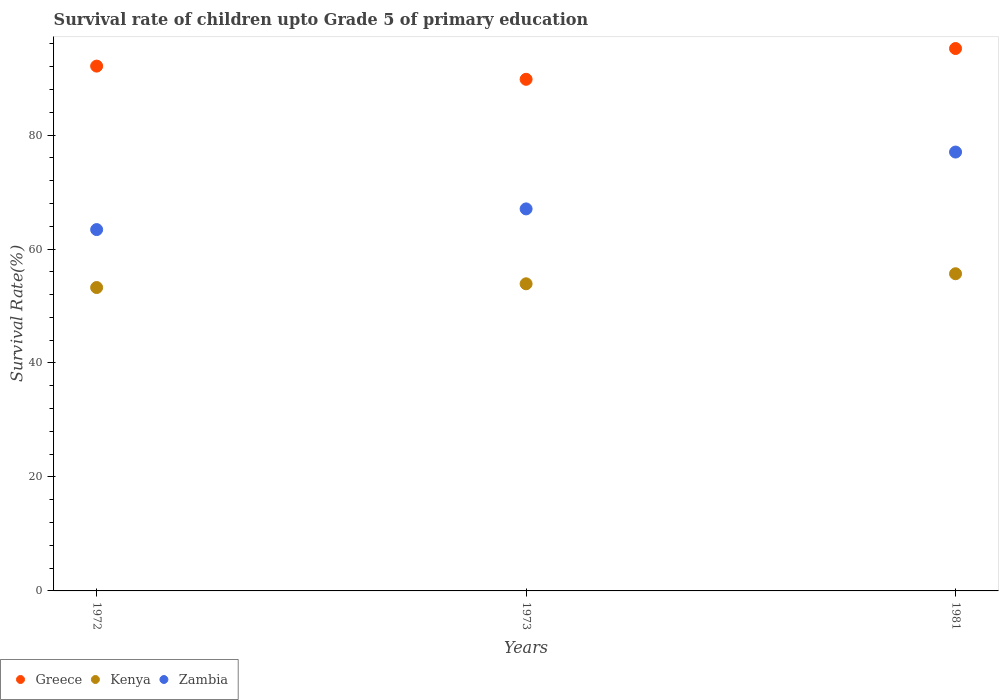What is the survival rate of children in Kenya in 1972?
Your answer should be compact. 53.24. Across all years, what is the maximum survival rate of children in Greece?
Provide a succinct answer. 95.19. Across all years, what is the minimum survival rate of children in Greece?
Ensure brevity in your answer.  89.79. In which year was the survival rate of children in Kenya maximum?
Give a very brief answer. 1981. In which year was the survival rate of children in Kenya minimum?
Your response must be concise. 1972. What is the total survival rate of children in Zambia in the graph?
Provide a short and direct response. 207.48. What is the difference between the survival rate of children in Greece in 1973 and that in 1981?
Ensure brevity in your answer.  -5.4. What is the difference between the survival rate of children in Zambia in 1972 and the survival rate of children in Kenya in 1981?
Your response must be concise. 7.75. What is the average survival rate of children in Greece per year?
Keep it short and to the point. 92.36. In the year 1973, what is the difference between the survival rate of children in Kenya and survival rate of children in Zambia?
Your response must be concise. -13.15. In how many years, is the survival rate of children in Zambia greater than 68 %?
Provide a short and direct response. 1. What is the ratio of the survival rate of children in Zambia in 1972 to that in 1973?
Provide a succinct answer. 0.95. Is the survival rate of children in Zambia in 1972 less than that in 1973?
Provide a short and direct response. Yes. Is the difference between the survival rate of children in Kenya in 1973 and 1981 greater than the difference between the survival rate of children in Zambia in 1973 and 1981?
Offer a terse response. Yes. What is the difference between the highest and the second highest survival rate of children in Kenya?
Give a very brief answer. 1.76. What is the difference between the highest and the lowest survival rate of children in Greece?
Offer a very short reply. 5.4. Is it the case that in every year, the sum of the survival rate of children in Kenya and survival rate of children in Zambia  is greater than the survival rate of children in Greece?
Give a very brief answer. Yes. Does the survival rate of children in Zambia monotonically increase over the years?
Make the answer very short. Yes. Is the survival rate of children in Kenya strictly greater than the survival rate of children in Greece over the years?
Your answer should be compact. No. How many dotlines are there?
Offer a very short reply. 3. What is the difference between two consecutive major ticks on the Y-axis?
Your answer should be very brief. 20. Does the graph contain any zero values?
Your response must be concise. No. Where does the legend appear in the graph?
Your answer should be very brief. Bottom left. How are the legend labels stacked?
Ensure brevity in your answer.  Horizontal. What is the title of the graph?
Provide a short and direct response. Survival rate of children upto Grade 5 of primary education. What is the label or title of the X-axis?
Offer a very short reply. Years. What is the label or title of the Y-axis?
Your response must be concise. Survival Rate(%). What is the Survival Rate(%) in Greece in 1972?
Provide a succinct answer. 92.1. What is the Survival Rate(%) in Kenya in 1972?
Ensure brevity in your answer.  53.24. What is the Survival Rate(%) of Zambia in 1972?
Your response must be concise. 63.41. What is the Survival Rate(%) of Greece in 1973?
Keep it short and to the point. 89.79. What is the Survival Rate(%) of Kenya in 1973?
Keep it short and to the point. 53.9. What is the Survival Rate(%) of Zambia in 1973?
Offer a terse response. 67.04. What is the Survival Rate(%) of Greece in 1981?
Keep it short and to the point. 95.19. What is the Survival Rate(%) in Kenya in 1981?
Offer a very short reply. 55.66. What is the Survival Rate(%) of Zambia in 1981?
Provide a short and direct response. 77.02. Across all years, what is the maximum Survival Rate(%) of Greece?
Keep it short and to the point. 95.19. Across all years, what is the maximum Survival Rate(%) in Kenya?
Your answer should be very brief. 55.66. Across all years, what is the maximum Survival Rate(%) in Zambia?
Your answer should be very brief. 77.02. Across all years, what is the minimum Survival Rate(%) in Greece?
Offer a terse response. 89.79. Across all years, what is the minimum Survival Rate(%) of Kenya?
Keep it short and to the point. 53.24. Across all years, what is the minimum Survival Rate(%) of Zambia?
Make the answer very short. 63.41. What is the total Survival Rate(%) of Greece in the graph?
Your response must be concise. 277.08. What is the total Survival Rate(%) in Kenya in the graph?
Keep it short and to the point. 162.8. What is the total Survival Rate(%) of Zambia in the graph?
Your response must be concise. 207.48. What is the difference between the Survival Rate(%) in Greece in 1972 and that in 1973?
Your answer should be very brief. 2.31. What is the difference between the Survival Rate(%) in Kenya in 1972 and that in 1973?
Keep it short and to the point. -0.66. What is the difference between the Survival Rate(%) of Zambia in 1972 and that in 1973?
Give a very brief answer. -3.63. What is the difference between the Survival Rate(%) in Greece in 1972 and that in 1981?
Make the answer very short. -3.09. What is the difference between the Survival Rate(%) of Kenya in 1972 and that in 1981?
Give a very brief answer. -2.42. What is the difference between the Survival Rate(%) in Zambia in 1972 and that in 1981?
Offer a terse response. -13.61. What is the difference between the Survival Rate(%) of Greece in 1973 and that in 1981?
Provide a succinct answer. -5.4. What is the difference between the Survival Rate(%) in Kenya in 1973 and that in 1981?
Make the answer very short. -1.76. What is the difference between the Survival Rate(%) in Zambia in 1973 and that in 1981?
Offer a terse response. -9.98. What is the difference between the Survival Rate(%) in Greece in 1972 and the Survival Rate(%) in Kenya in 1973?
Offer a terse response. 38.2. What is the difference between the Survival Rate(%) in Greece in 1972 and the Survival Rate(%) in Zambia in 1973?
Keep it short and to the point. 25.06. What is the difference between the Survival Rate(%) in Kenya in 1972 and the Survival Rate(%) in Zambia in 1973?
Keep it short and to the point. -13.8. What is the difference between the Survival Rate(%) of Greece in 1972 and the Survival Rate(%) of Kenya in 1981?
Your answer should be compact. 36.44. What is the difference between the Survival Rate(%) of Greece in 1972 and the Survival Rate(%) of Zambia in 1981?
Your answer should be compact. 15.08. What is the difference between the Survival Rate(%) in Kenya in 1972 and the Survival Rate(%) in Zambia in 1981?
Ensure brevity in your answer.  -23.78. What is the difference between the Survival Rate(%) of Greece in 1973 and the Survival Rate(%) of Kenya in 1981?
Your answer should be very brief. 34.12. What is the difference between the Survival Rate(%) of Greece in 1973 and the Survival Rate(%) of Zambia in 1981?
Keep it short and to the point. 12.77. What is the difference between the Survival Rate(%) of Kenya in 1973 and the Survival Rate(%) of Zambia in 1981?
Make the answer very short. -23.12. What is the average Survival Rate(%) of Greece per year?
Ensure brevity in your answer.  92.36. What is the average Survival Rate(%) in Kenya per year?
Give a very brief answer. 54.27. What is the average Survival Rate(%) of Zambia per year?
Offer a terse response. 69.16. In the year 1972, what is the difference between the Survival Rate(%) in Greece and Survival Rate(%) in Kenya?
Offer a terse response. 38.86. In the year 1972, what is the difference between the Survival Rate(%) of Greece and Survival Rate(%) of Zambia?
Make the answer very short. 28.69. In the year 1972, what is the difference between the Survival Rate(%) in Kenya and Survival Rate(%) in Zambia?
Your response must be concise. -10.17. In the year 1973, what is the difference between the Survival Rate(%) in Greece and Survival Rate(%) in Kenya?
Offer a very short reply. 35.89. In the year 1973, what is the difference between the Survival Rate(%) of Greece and Survival Rate(%) of Zambia?
Keep it short and to the point. 22.74. In the year 1973, what is the difference between the Survival Rate(%) in Kenya and Survival Rate(%) in Zambia?
Make the answer very short. -13.15. In the year 1981, what is the difference between the Survival Rate(%) in Greece and Survival Rate(%) in Kenya?
Your answer should be very brief. 39.53. In the year 1981, what is the difference between the Survival Rate(%) of Greece and Survival Rate(%) of Zambia?
Give a very brief answer. 18.17. In the year 1981, what is the difference between the Survival Rate(%) of Kenya and Survival Rate(%) of Zambia?
Your response must be concise. -21.36. What is the ratio of the Survival Rate(%) in Greece in 1972 to that in 1973?
Provide a succinct answer. 1.03. What is the ratio of the Survival Rate(%) in Kenya in 1972 to that in 1973?
Your response must be concise. 0.99. What is the ratio of the Survival Rate(%) of Zambia in 1972 to that in 1973?
Give a very brief answer. 0.95. What is the ratio of the Survival Rate(%) of Greece in 1972 to that in 1981?
Your answer should be very brief. 0.97. What is the ratio of the Survival Rate(%) of Kenya in 1972 to that in 1981?
Give a very brief answer. 0.96. What is the ratio of the Survival Rate(%) in Zambia in 1972 to that in 1981?
Keep it short and to the point. 0.82. What is the ratio of the Survival Rate(%) in Greece in 1973 to that in 1981?
Give a very brief answer. 0.94. What is the ratio of the Survival Rate(%) in Kenya in 1973 to that in 1981?
Your answer should be compact. 0.97. What is the ratio of the Survival Rate(%) in Zambia in 1973 to that in 1981?
Your response must be concise. 0.87. What is the difference between the highest and the second highest Survival Rate(%) of Greece?
Keep it short and to the point. 3.09. What is the difference between the highest and the second highest Survival Rate(%) of Kenya?
Your response must be concise. 1.76. What is the difference between the highest and the second highest Survival Rate(%) of Zambia?
Your response must be concise. 9.98. What is the difference between the highest and the lowest Survival Rate(%) in Greece?
Keep it short and to the point. 5.4. What is the difference between the highest and the lowest Survival Rate(%) of Kenya?
Your response must be concise. 2.42. What is the difference between the highest and the lowest Survival Rate(%) of Zambia?
Offer a very short reply. 13.61. 